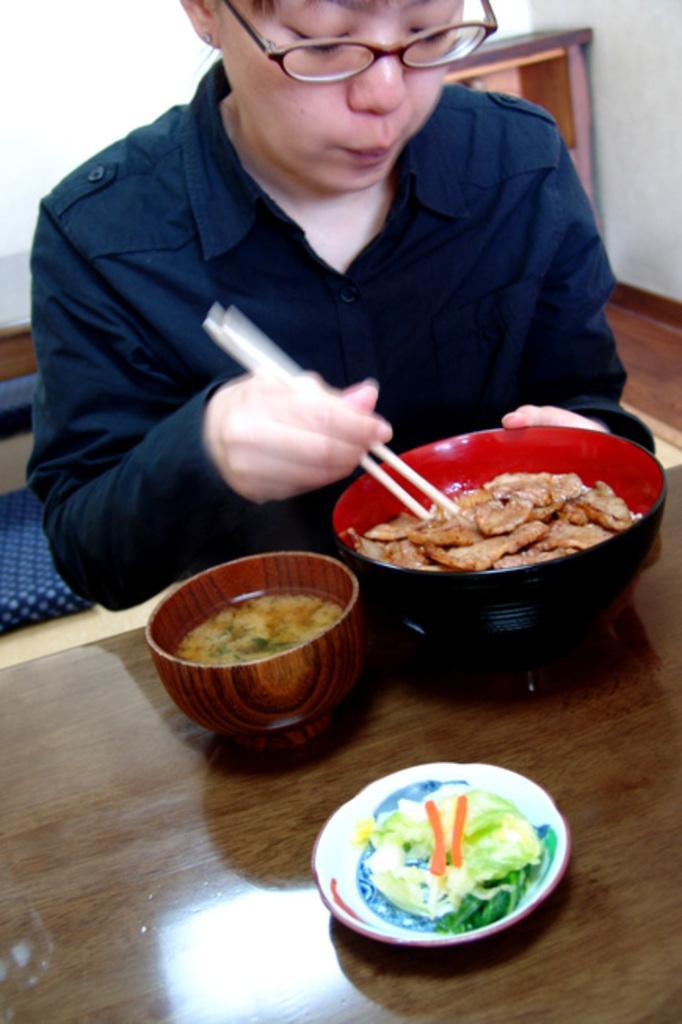In one or two sentences, can you explain what this image depicts? There is a man sitting on the dining table eating food from the bowl with the help of chop sticks and few other bowls are also there on table. 